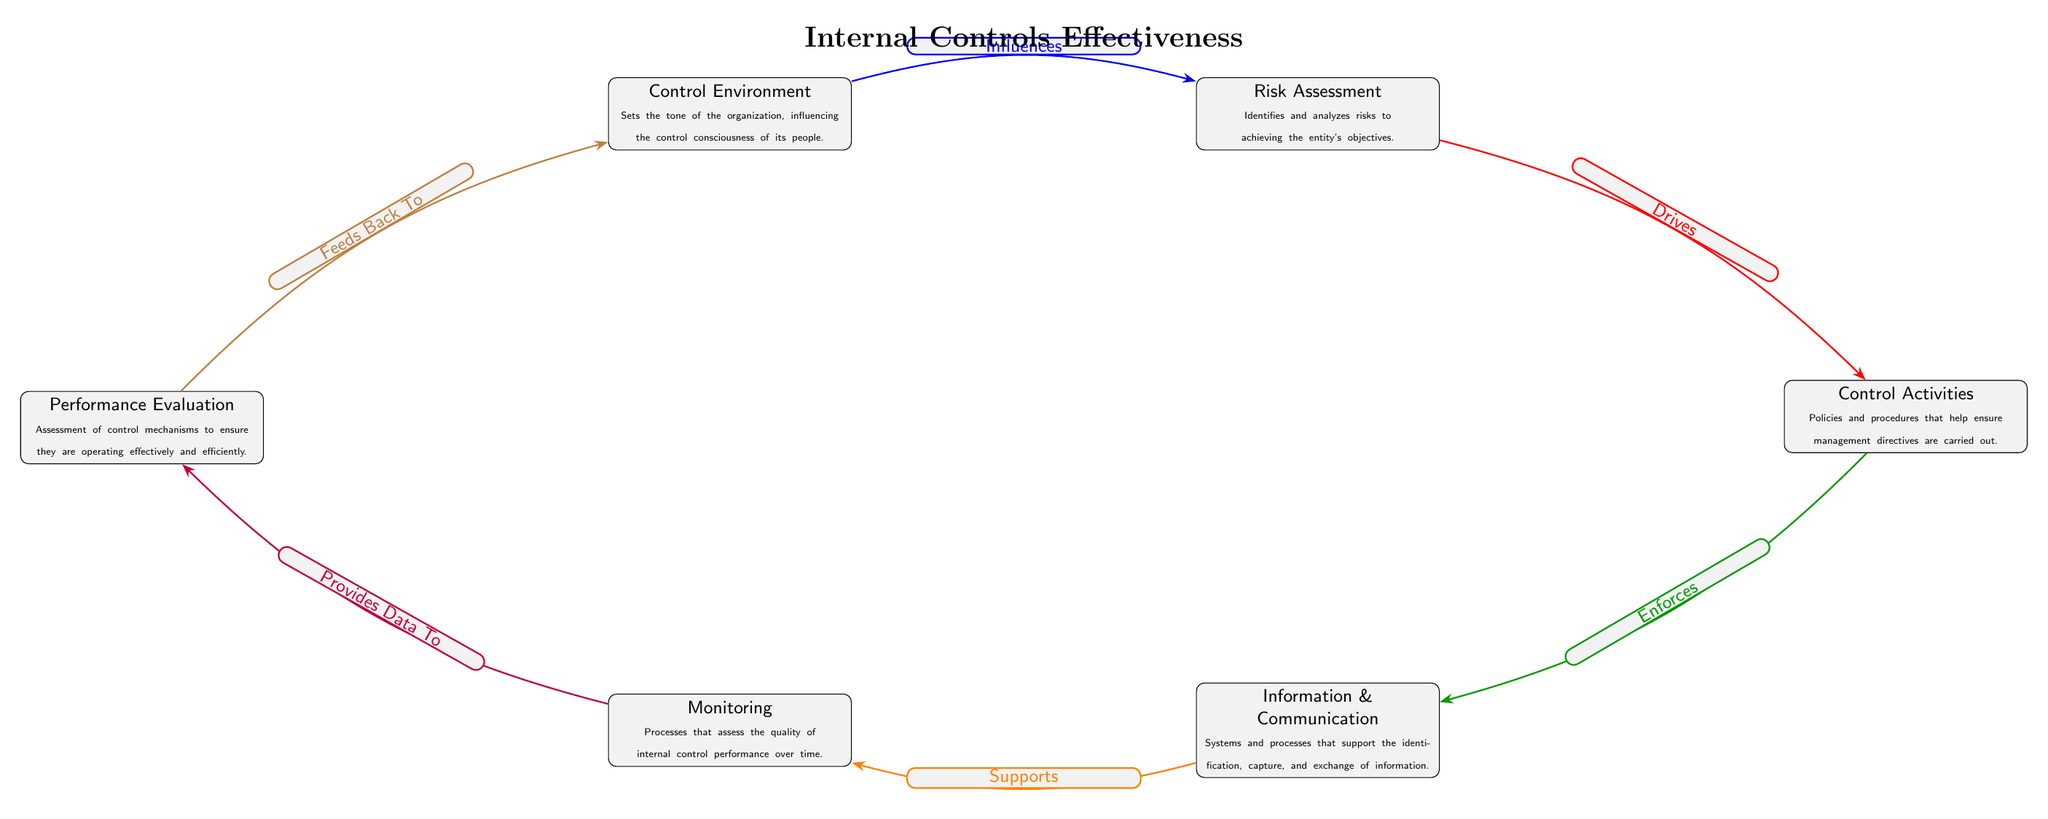What are the two key aspects of the Control Environment? The Control Environment has a dual focus: it sets the tone of the organization and influences the control consciousness of its people. These aspects work together to create an ethical framework for decision-making.
Answer: Sets the tone, Influences control consciousness How many control mechanisms are depicted in the diagram? By counting the nodes, the diagram shows a total of six control mechanisms: Control Environment, Risk Assessment, Control Activities, Information & Communication, Monitoring, and Performance Evaluation.
Answer: Six What is the relationship between Risk Assessment and Control Activities? The diagram indicates that Risk Assessment "Drives" Control Activities, suggesting that the identification and analysis of risks directly influence the policies and procedures put in place to manage those risks.
Answer: Drives Which mechanism is the first in the sequence of flow? The diagram sequence starts with the Control Environment, which establishes the foundational tone and influences all subsequent mechanisms in the internal control process.
Answer: Control Environment What does Performance Evaluation provide to? In the diagram, Performance Evaluation "Provides Data To" the Monitoring mechanism, indicating that the assessment of control mechanisms generates information necessary for ongoing monitoring efforts.
Answer: Monitoring What does Information & Communication Support? Information & Communication "Supports" the Monitoring mechanism in the diagram, showing that effective information exchange is essential for assessing the capability and functionality of internal controls over time.
Answer: Monitoring How does Monitoring relate to Control Environment? Monitoring "Feeds Back To" the Control Environment, which illustrates a feedback loop where the assessment of monitoring mechanisms helps inform and potentially reshape the control environment.
Answer: Feeds Back To What is the color of the arrow that shows the relationship between Control Activities and Information & Communication? In the diagram, the relationship between Control Activities and Information & Communication is represented by a green arrow, indicating a supportive framework in executing communication systems.
Answer: Green 